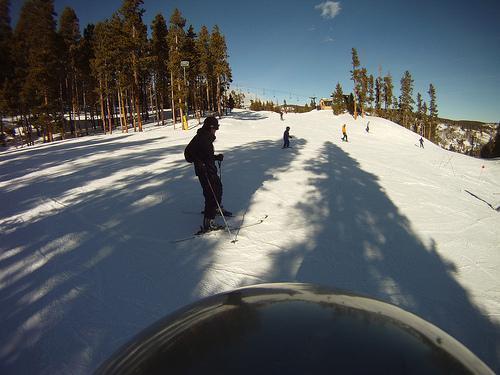How many people skiing?
Give a very brief answer. 6. 